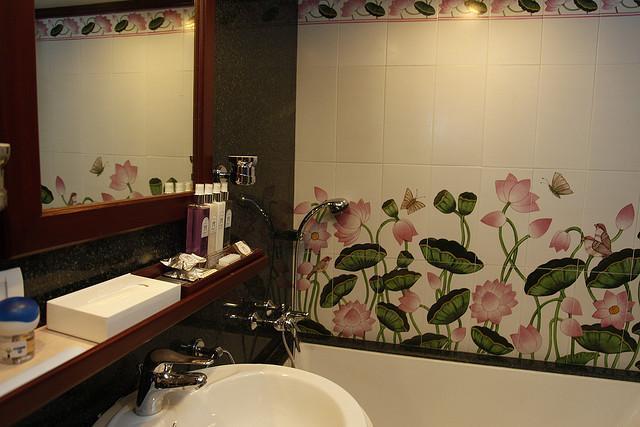How many people are wearing glasses?
Give a very brief answer. 0. 